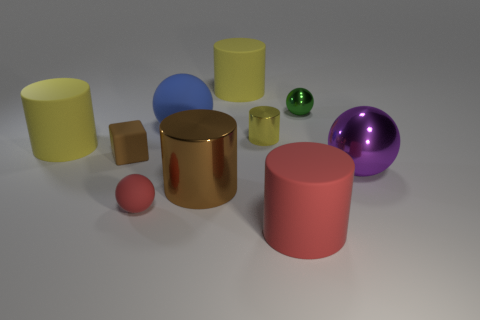How many yellow cylinders must be subtracted to get 1 yellow cylinders? 2 Subtract all yellow shiny cylinders. How many cylinders are left? 4 Subtract all green spheres. How many spheres are left? 3 Subtract 3 spheres. How many spheres are left? 1 Subtract all brown cylinders. How many yellow cubes are left? 0 Subtract all cyan rubber cylinders. Subtract all large blue things. How many objects are left? 9 Add 4 yellow cylinders. How many yellow cylinders are left? 7 Add 6 large yellow matte objects. How many large yellow matte objects exist? 8 Subtract 0 cyan balls. How many objects are left? 10 Subtract all spheres. How many objects are left? 6 